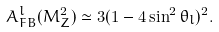<formula> <loc_0><loc_0><loc_500><loc_500>A _ { F B } ^ { l } ( M _ { Z } ^ { 2 } ) \simeq 3 ( 1 - 4 \sin ^ { 2 } \theta _ { l } ) ^ { 2 } .</formula> 